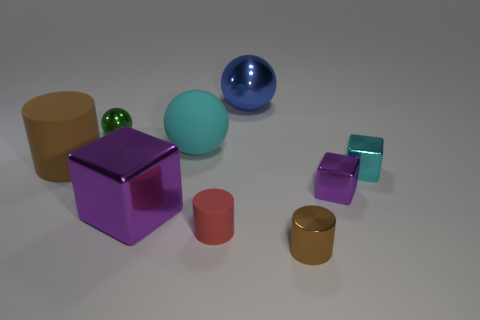How many objects are there in the image, and can you describe their colors? There are seven objects in the image. Starting from the largest, there's a blue sphere, a purple cube, a large beige cylinder, a translucent aqua cube, a small shiny green sphere, a smaller beige cylinder, and a miniature orange cylinder. 